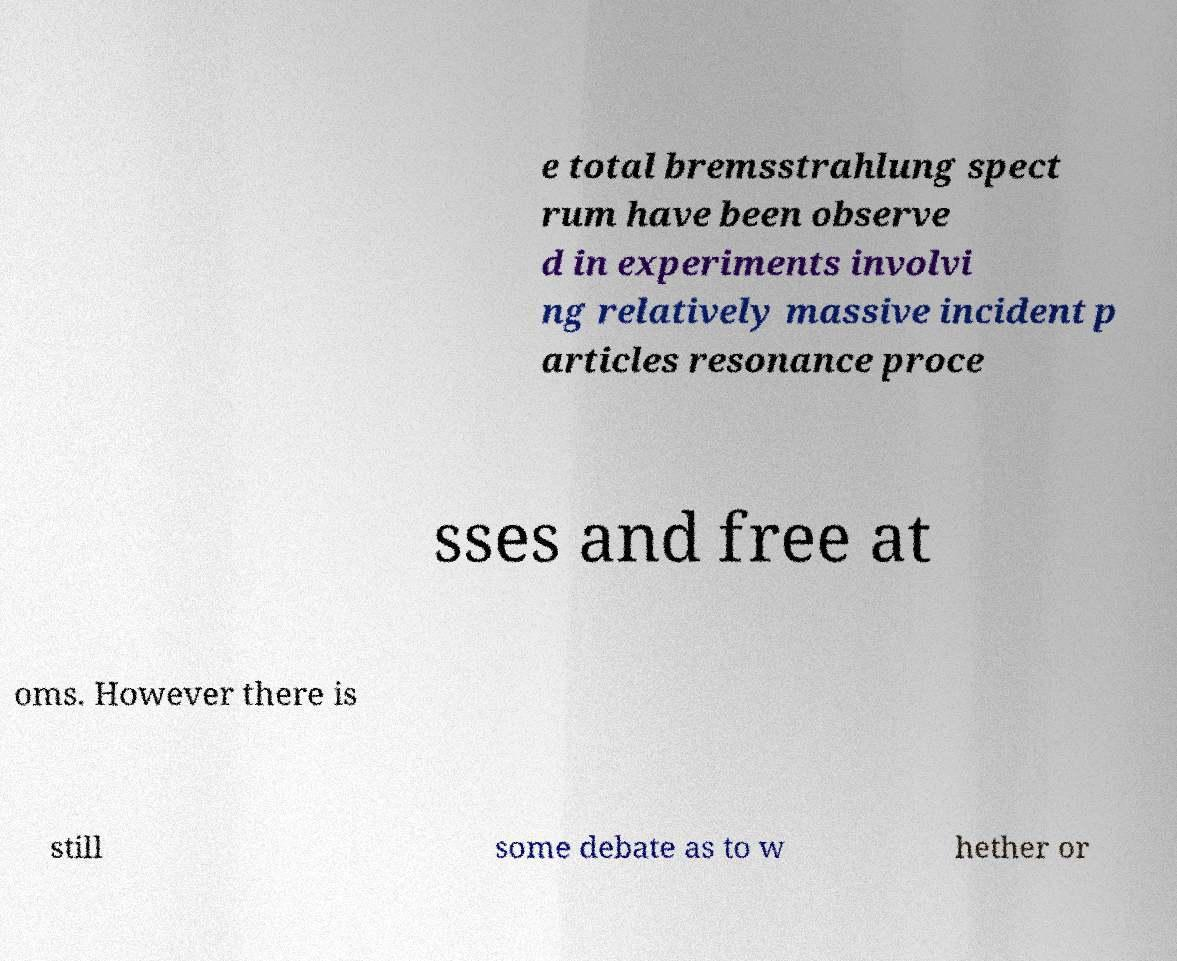Could you assist in decoding the text presented in this image and type it out clearly? e total bremsstrahlung spect rum have been observe d in experiments involvi ng relatively massive incident p articles resonance proce sses and free at oms. However there is still some debate as to w hether or 